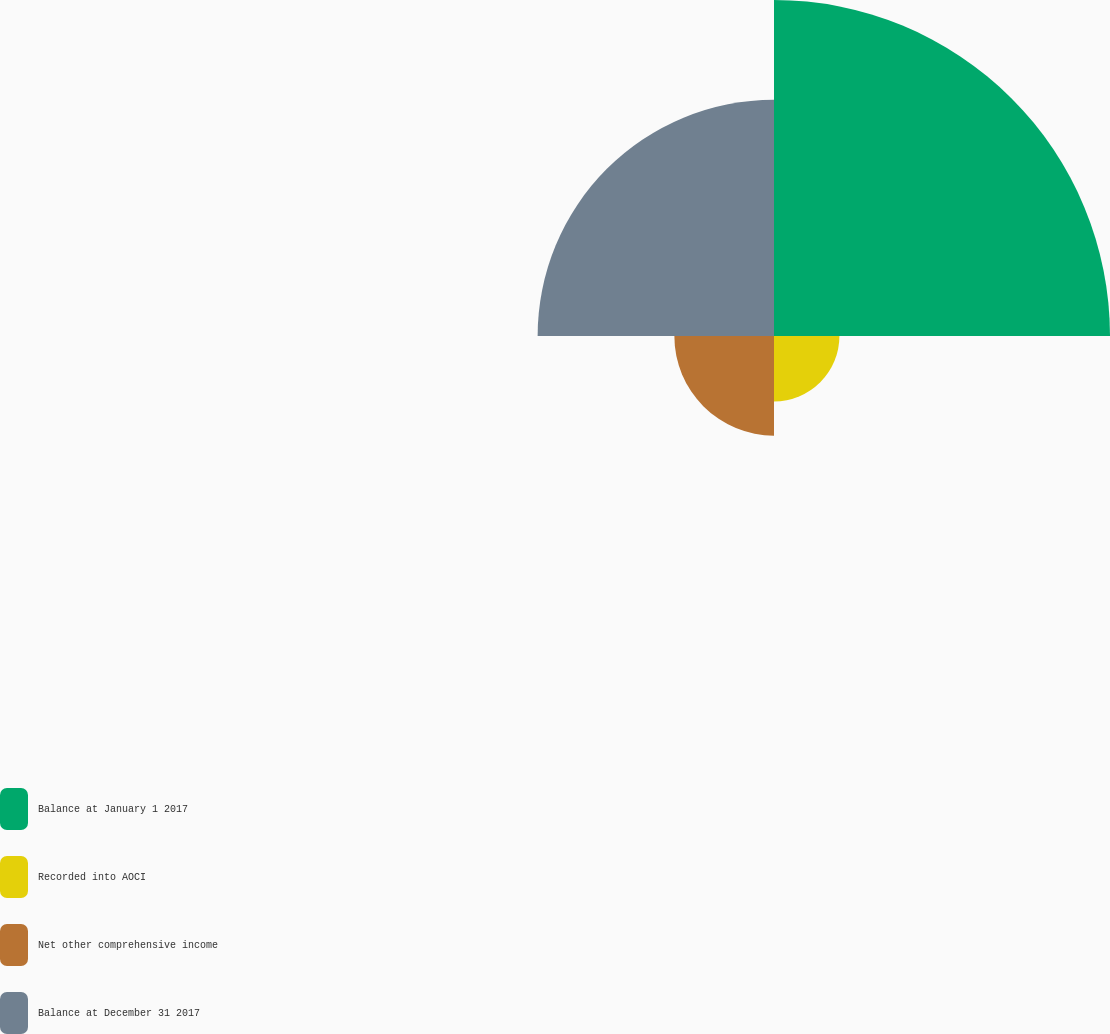Convert chart. <chart><loc_0><loc_0><loc_500><loc_500><pie_chart><fcel>Balance at January 1 2017<fcel>Recorded into AOCI<fcel>Net other comprehensive income<fcel>Balance at December 31 2017<nl><fcel>45.56%<fcel>8.87%<fcel>13.51%<fcel>32.05%<nl></chart> 